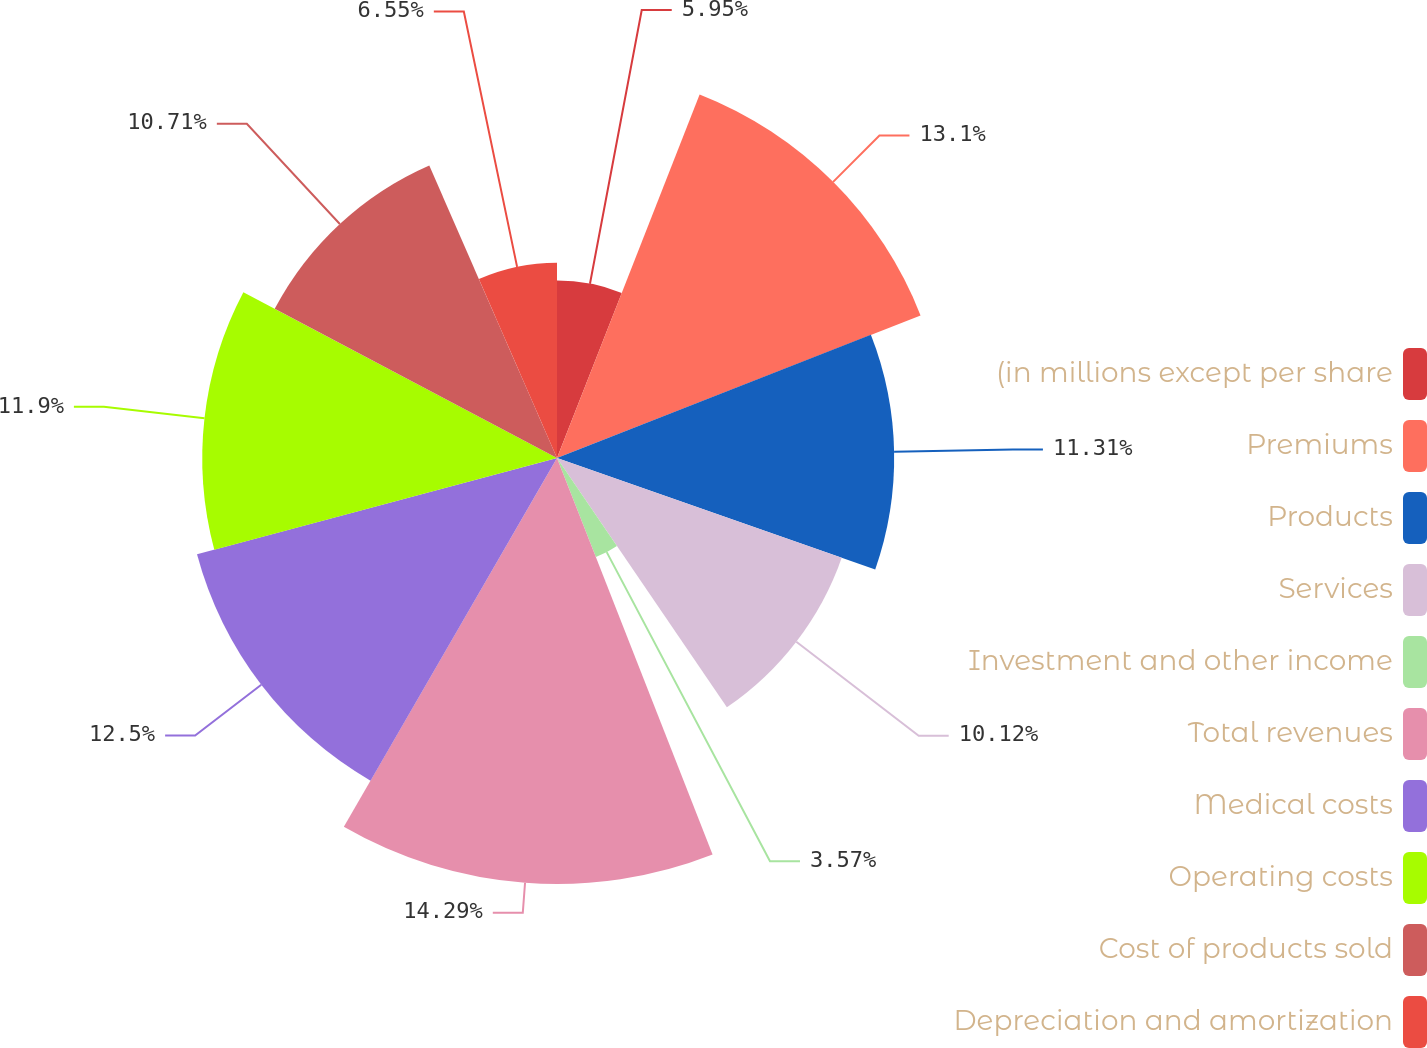Convert chart. <chart><loc_0><loc_0><loc_500><loc_500><pie_chart><fcel>(in millions except per share<fcel>Premiums<fcel>Products<fcel>Services<fcel>Investment and other income<fcel>Total revenues<fcel>Medical costs<fcel>Operating costs<fcel>Cost of products sold<fcel>Depreciation and amortization<nl><fcel>5.95%<fcel>13.1%<fcel>11.31%<fcel>10.12%<fcel>3.57%<fcel>14.29%<fcel>12.5%<fcel>11.9%<fcel>10.71%<fcel>6.55%<nl></chart> 